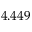<formula> <loc_0><loc_0><loc_500><loc_500>4 . 4 4 9</formula> 